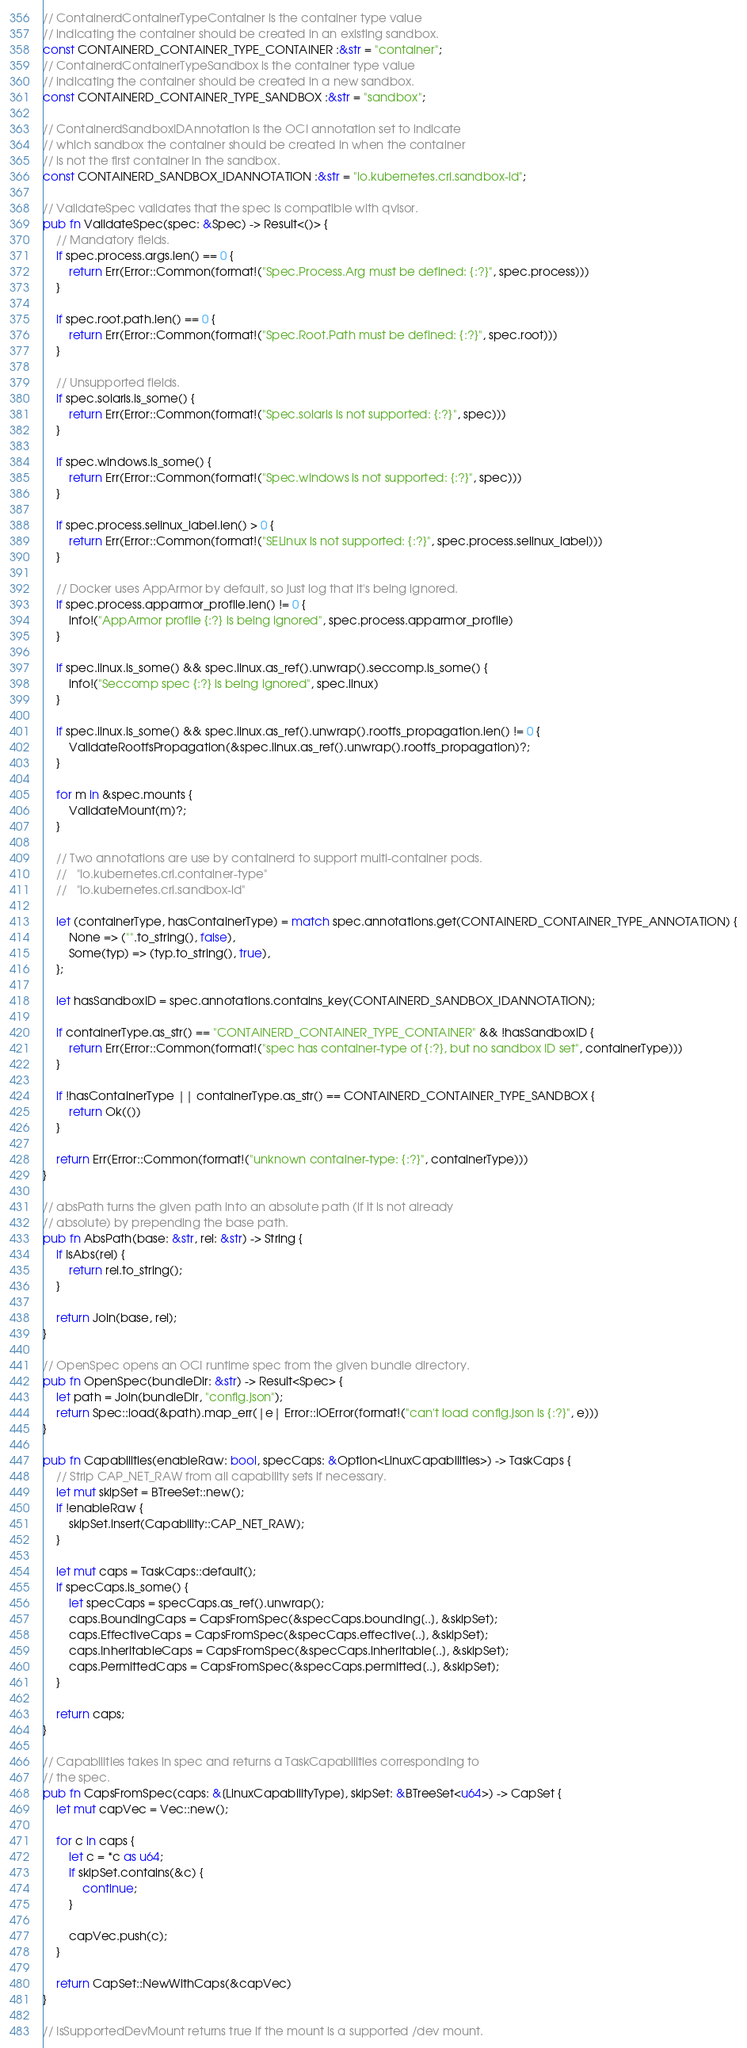Convert code to text. <code><loc_0><loc_0><loc_500><loc_500><_Rust_>// ContainerdContainerTypeContainer is the container type value
// indicating the container should be created in an existing sandbox.
const CONTAINERD_CONTAINER_TYPE_CONTAINER :&str = "container";
// ContainerdContainerTypeSandbox is the container type value
// indicating the container should be created in a new sandbox.
const CONTAINERD_CONTAINER_TYPE_SANDBOX :&str = "sandbox";

// ContainerdSandboxIDAnnotation is the OCI annotation set to indicate
// which sandbox the container should be created in when the container
// is not the first container in the sandbox.
const CONTAINERD_SANDBOX_IDANNOTATION :&str = "io.kubernetes.cri.sandbox-id";

// ValidateSpec validates that the spec is compatible with qvisor.
pub fn ValidateSpec(spec: &Spec) -> Result<()> {
    // Mandatory fields.
    if spec.process.args.len() == 0 {
        return Err(Error::Common(format!("Spec.Process.Arg must be defined: {:?}", spec.process)))
    }

    if spec.root.path.len() == 0 {
        return Err(Error::Common(format!("Spec.Root.Path must be defined: {:?}", spec.root)))
    }

    // Unsupported fields.
    if spec.solaris.is_some() {
        return Err(Error::Common(format!("Spec.solaris is not supported: {:?}", spec)))
    }

    if spec.windows.is_some() {
        return Err(Error::Common(format!("Spec.windows is not supported: {:?}", spec)))
    }

    if spec.process.selinux_label.len() > 0 {
        return Err(Error::Common(format!("SELinux is not supported: {:?}", spec.process.selinux_label)))
    }

    // Docker uses AppArmor by default, so just log that it's being ignored.
    if spec.process.apparmor_profile.len() != 0 {
        info!("AppArmor profile {:?} is being ignored", spec.process.apparmor_profile)
    }

    if spec.linux.is_some() && spec.linux.as_ref().unwrap().seccomp.is_some() {
        info!("Seccomp spec {:?} is being ignored", spec.linux)
    }

    if spec.linux.is_some() && spec.linux.as_ref().unwrap().rootfs_propagation.len() != 0 {
        ValidateRootfsPropagation(&spec.linux.as_ref().unwrap().rootfs_propagation)?;
    }

    for m in &spec.mounts {
        ValidateMount(m)?;
    }

    // Two annotations are use by containerd to support multi-container pods.
    //   "io.kubernetes.cri.container-type"
    //   "io.kubernetes.cri.sandbox-id"

    let (containerType, hasContainerType) = match spec.annotations.get(CONTAINERD_CONTAINER_TYPE_ANNOTATION) {
        None => ("".to_string(), false),
        Some(typ) => (typ.to_string(), true),
    };

    let hasSandboxID = spec.annotations.contains_key(CONTAINERD_SANDBOX_IDANNOTATION);

    if containerType.as_str() == "CONTAINERD_CONTAINER_TYPE_CONTAINER" && !hasSandboxID {
        return Err(Error::Common(format!("spec has container-type of {:?}, but no sandbox ID set", containerType)))
    }

    if !hasContainerType || containerType.as_str() == CONTAINERD_CONTAINER_TYPE_SANDBOX {
        return Ok(())
    }

    return Err(Error::Common(format!("unknown container-type: {:?}", containerType)))
}

// absPath turns the given path into an absolute path (if it is not already
// absolute) by prepending the base path.
pub fn AbsPath(base: &str, rel: &str) -> String {
    if IsAbs(rel) {
        return rel.to_string();
    }

    return Join(base, rel);
}

// OpenSpec opens an OCI runtime spec from the given bundle directory.
pub fn OpenSpec(bundleDir: &str) -> Result<Spec> {
    let path = Join(bundleDir, "config.json");
    return Spec::load(&path).map_err(|e| Error::IOError(format!("can't load config.json is {:?}", e)))
}

pub fn Capabilities(enableRaw: bool, specCaps: &Option<LinuxCapabilities>) -> TaskCaps {
    // Strip CAP_NET_RAW from all capability sets if necessary.
    let mut skipSet = BTreeSet::new();
    if !enableRaw {
        skipSet.insert(Capability::CAP_NET_RAW);
    }

    let mut caps = TaskCaps::default();
    if specCaps.is_some() {
        let specCaps = specCaps.as_ref().unwrap();
        caps.BoundingCaps = CapsFromSpec(&specCaps.bounding[..], &skipSet);
        caps.EffectiveCaps = CapsFromSpec(&specCaps.effective[..], &skipSet);
        caps.InheritableCaps = CapsFromSpec(&specCaps.inheritable[..], &skipSet);
        caps.PermittedCaps = CapsFromSpec(&specCaps.permitted[..], &skipSet);
    }

    return caps;
}

// Capabilities takes in spec and returns a TaskCapabilities corresponding to
// the spec.
pub fn CapsFromSpec(caps: &[LinuxCapabilityType], skipSet: &BTreeSet<u64>) -> CapSet {
    let mut capVec = Vec::new();

    for c in caps {
        let c = *c as u64;
        if skipSet.contains(&c) {
            continue;
        }

        capVec.push(c);
    }

    return CapSet::NewWithCaps(&capVec)
}

// IsSupportedDevMount returns true if the mount is a supported /dev mount.</code> 